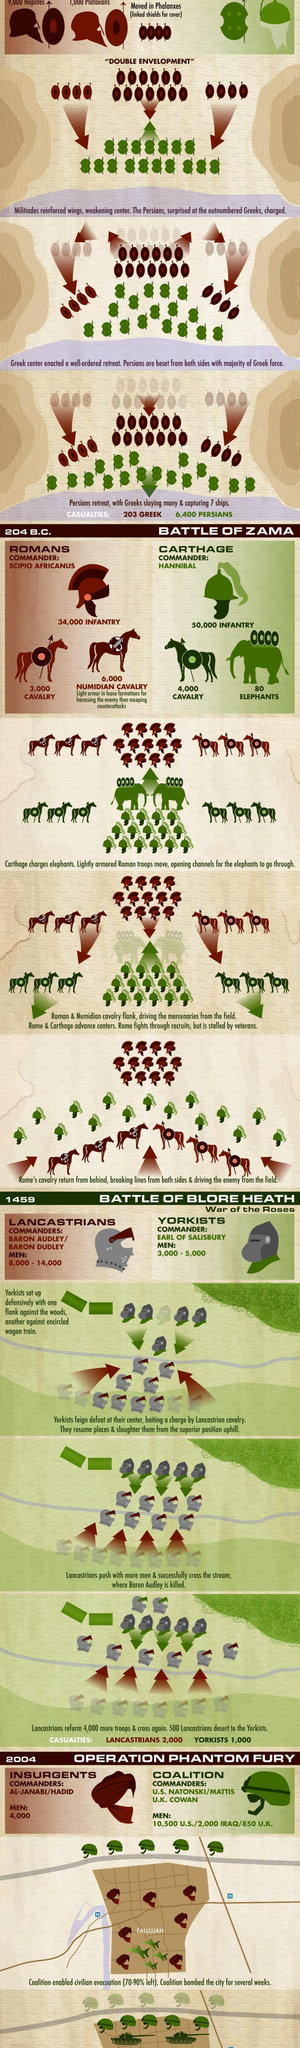when was battle of Blore Heath happened?
Answer the question with a short phrase. 1459 who had more infantry during the battle of zama? Carthage who had more more causalities during the battle of Blore Heath? Lancastrians who had more more strength during the battle of Blore Heath? Lancastrians who had more more strength during the operation Phantom Fury? Coalition what was the total strength of Coalition during the operation Phantom Fury? 13350 